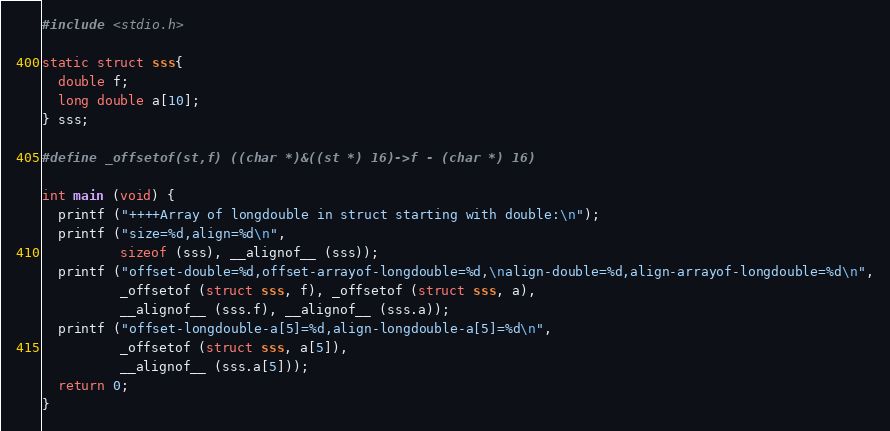<code> <loc_0><loc_0><loc_500><loc_500><_C_>#include <stdio.h>

static struct sss{
  double f;
  long double a[10];
} sss;

#define _offsetof(st,f) ((char *)&((st *) 16)->f - (char *) 16)

int main (void) {
  printf ("++++Array of longdouble in struct starting with double:\n");
  printf ("size=%d,align=%d\n",
          sizeof (sss), __alignof__ (sss));
  printf ("offset-double=%d,offset-arrayof-longdouble=%d,\nalign-double=%d,align-arrayof-longdouble=%d\n",
          _offsetof (struct sss, f), _offsetof (struct sss, a),
          __alignof__ (sss.f), __alignof__ (sss.a));
  printf ("offset-longdouble-a[5]=%d,align-longdouble-a[5]=%d\n",
          _offsetof (struct sss, a[5]),
          __alignof__ (sss.a[5]));
  return 0;
}
</code> 